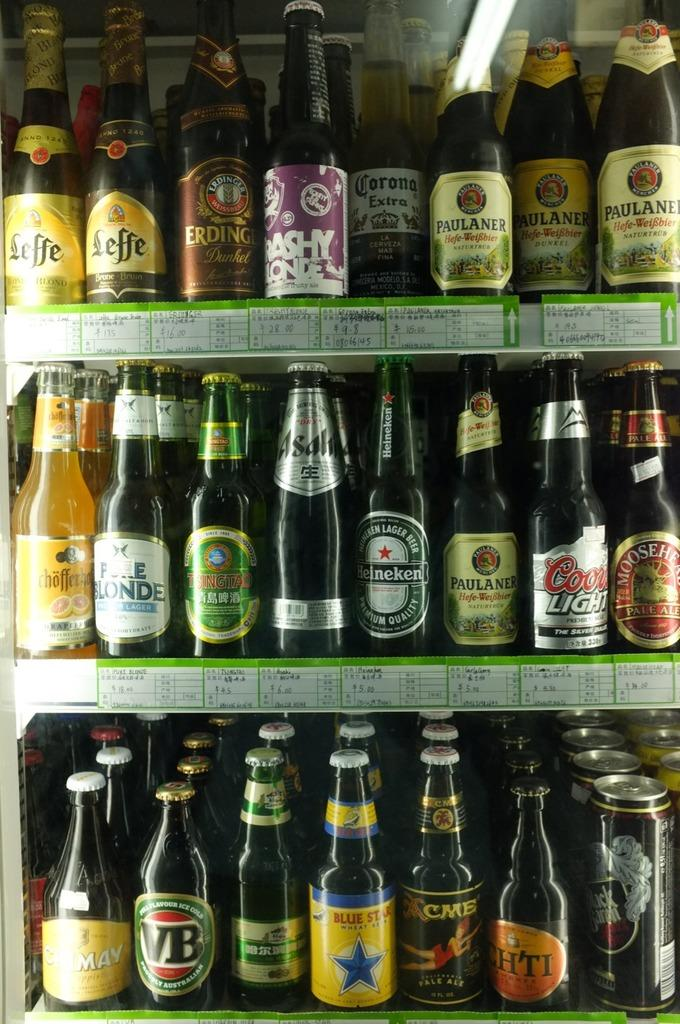<image>
Describe the image concisely. A store refrigerator is filled with domestic beers like Coors light, and imported beer like Heineken. 